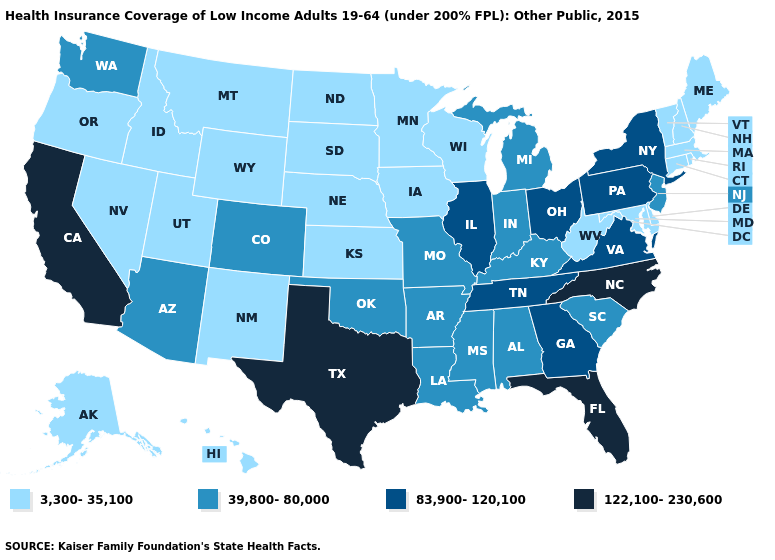Which states hav the highest value in the MidWest?
Write a very short answer. Illinois, Ohio. Which states have the lowest value in the USA?
Quick response, please. Alaska, Connecticut, Delaware, Hawaii, Idaho, Iowa, Kansas, Maine, Maryland, Massachusetts, Minnesota, Montana, Nebraska, Nevada, New Hampshire, New Mexico, North Dakota, Oregon, Rhode Island, South Dakota, Utah, Vermont, West Virginia, Wisconsin, Wyoming. Name the states that have a value in the range 39,800-80,000?
Keep it brief. Alabama, Arizona, Arkansas, Colorado, Indiana, Kentucky, Louisiana, Michigan, Mississippi, Missouri, New Jersey, Oklahoma, South Carolina, Washington. Name the states that have a value in the range 83,900-120,100?
Keep it brief. Georgia, Illinois, New York, Ohio, Pennsylvania, Tennessee, Virginia. What is the value of Pennsylvania?
Short answer required. 83,900-120,100. Is the legend a continuous bar?
Write a very short answer. No. Does Florida have the same value as New Jersey?
Give a very brief answer. No. Among the states that border Iowa , does South Dakota have the highest value?
Concise answer only. No. Does Texas have the highest value in the USA?
Quick response, please. Yes. What is the highest value in the USA?
Give a very brief answer. 122,100-230,600. Does Washington have the lowest value in the West?
Concise answer only. No. Among the states that border Michigan , does Wisconsin have the highest value?
Keep it brief. No. Which states have the lowest value in the USA?
Be succinct. Alaska, Connecticut, Delaware, Hawaii, Idaho, Iowa, Kansas, Maine, Maryland, Massachusetts, Minnesota, Montana, Nebraska, Nevada, New Hampshire, New Mexico, North Dakota, Oregon, Rhode Island, South Dakota, Utah, Vermont, West Virginia, Wisconsin, Wyoming. Does Texas have the highest value in the USA?
Be succinct. Yes. Does Illinois have the highest value in the MidWest?
Concise answer only. Yes. 